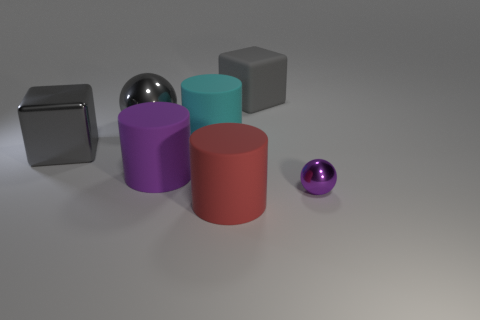Are there any large cyan spheres?
Your answer should be very brief. No. How many other things are there of the same color as the tiny object?
Keep it short and to the point. 1. Are there fewer red cylinders than tiny yellow matte things?
Your answer should be compact. No. The purple thing that is on the left side of the rubber block to the left of the purple metal object is what shape?
Make the answer very short. Cylinder. Are there any big gray shiny cubes behind the purple metallic ball?
Offer a terse response. Yes. There is a metal cube that is the same size as the red rubber cylinder; what is its color?
Ensure brevity in your answer.  Gray. What number of large gray objects have the same material as the small purple thing?
Provide a short and direct response. 2. How many other objects are there of the same size as the gray matte thing?
Keep it short and to the point. 5. Are there any purple objects that have the same size as the cyan thing?
Provide a short and direct response. Yes. There is a big thing behind the gray metallic ball; is its color the same as the big sphere?
Keep it short and to the point. Yes. 